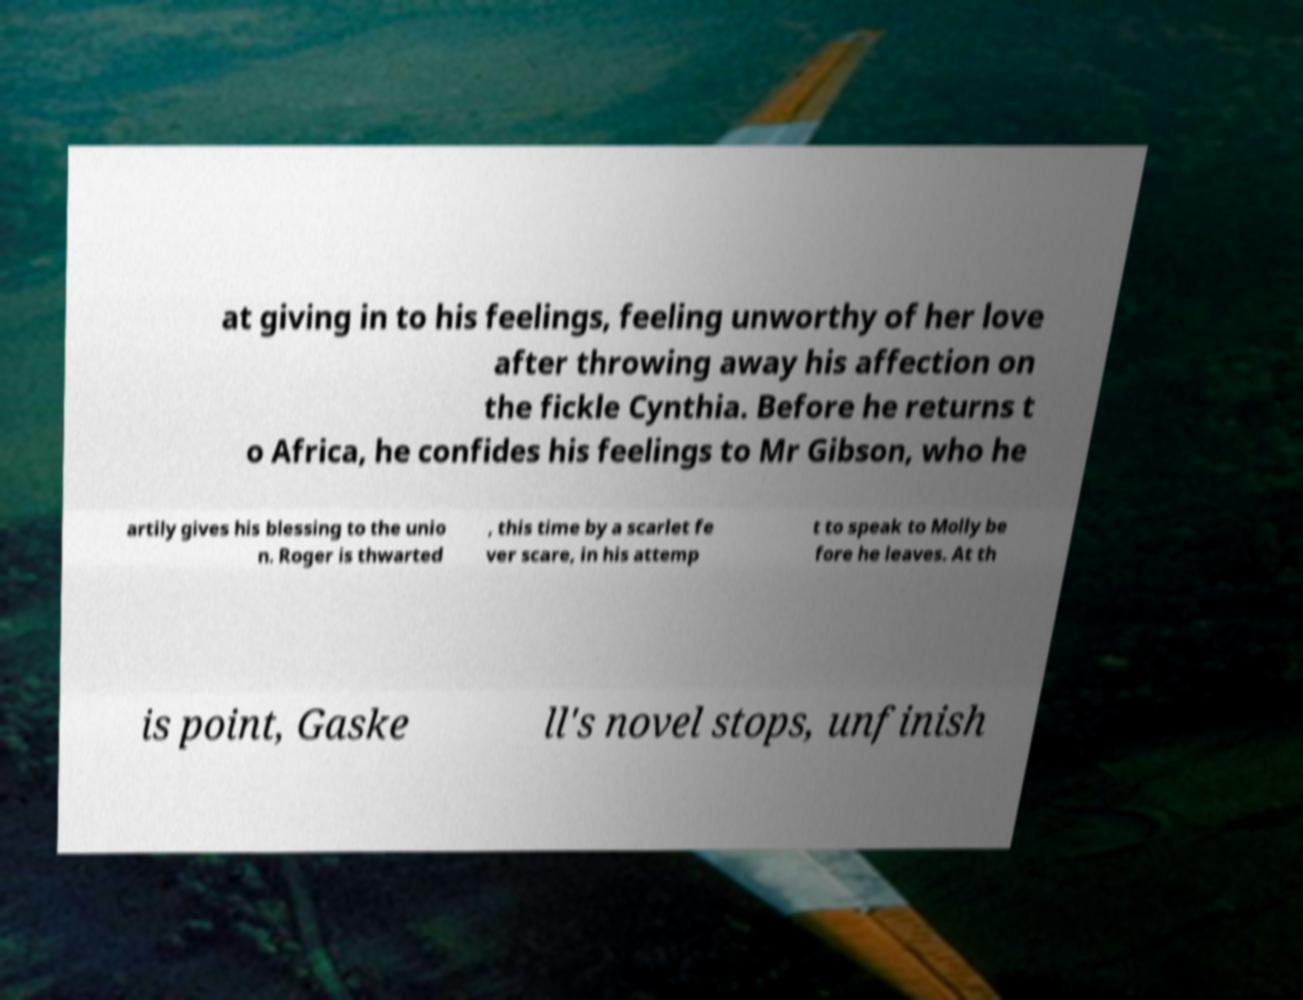Could you assist in decoding the text presented in this image and type it out clearly? at giving in to his feelings, feeling unworthy of her love after throwing away his affection on the fickle Cynthia. Before he returns t o Africa, he confides his feelings to Mr Gibson, who he artily gives his blessing to the unio n. Roger is thwarted , this time by a scarlet fe ver scare, in his attemp t to speak to Molly be fore he leaves. At th is point, Gaske ll's novel stops, unfinish 